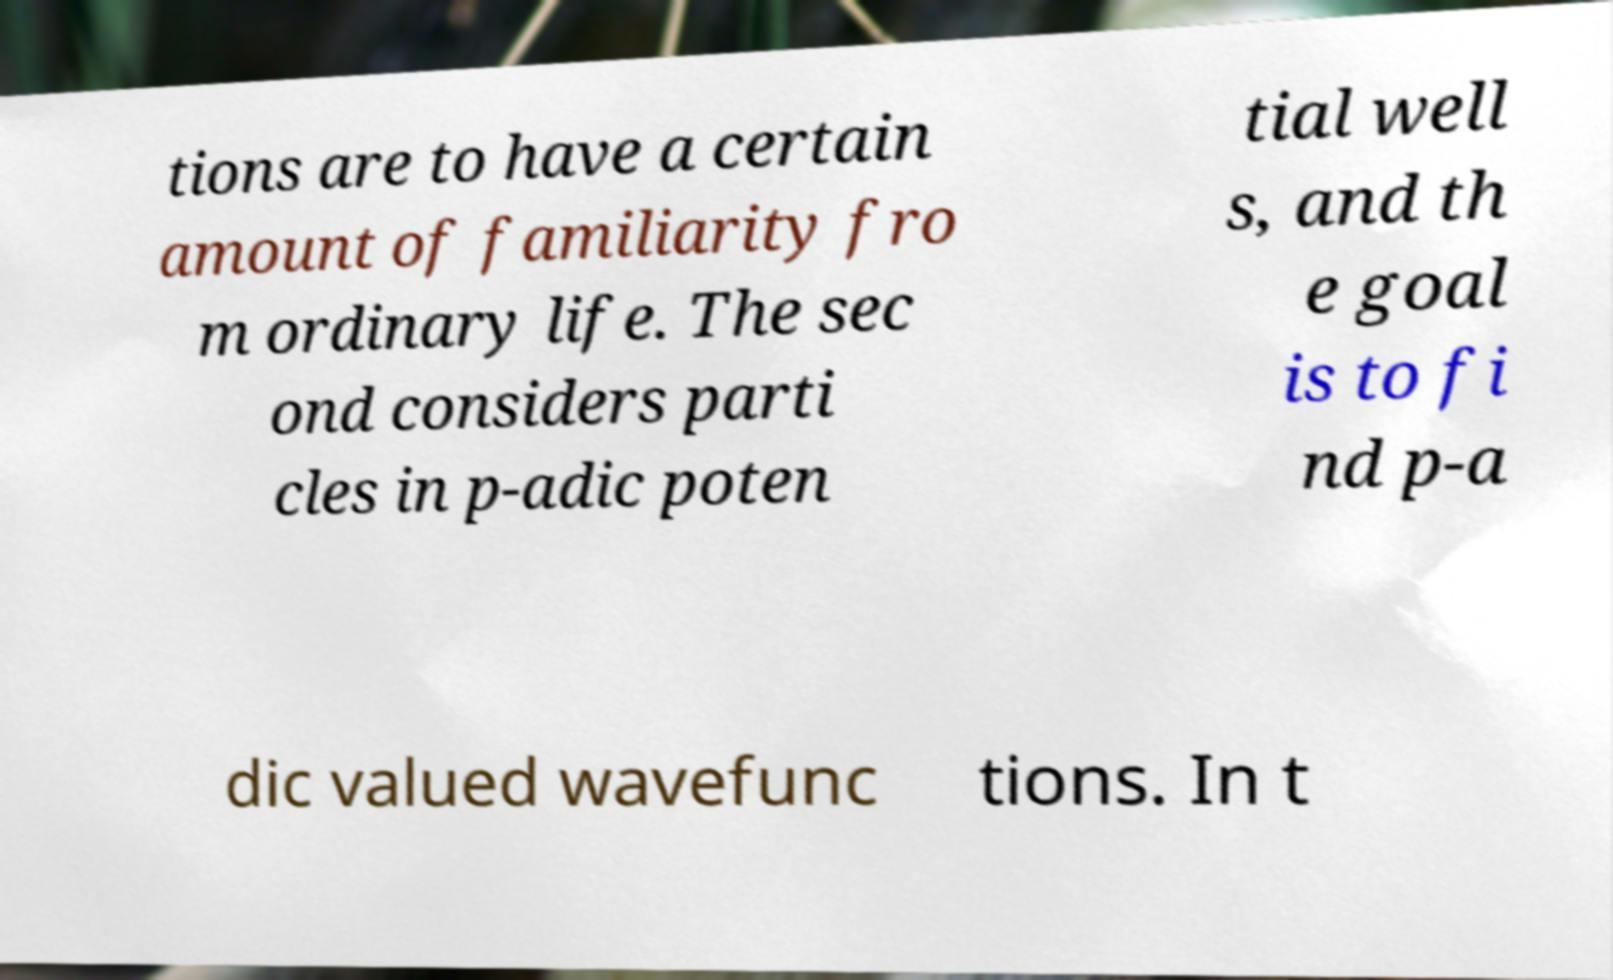For documentation purposes, I need the text within this image transcribed. Could you provide that? tions are to have a certain amount of familiarity fro m ordinary life. The sec ond considers parti cles in p-adic poten tial well s, and th e goal is to fi nd p-a dic valued wavefunc tions. In t 